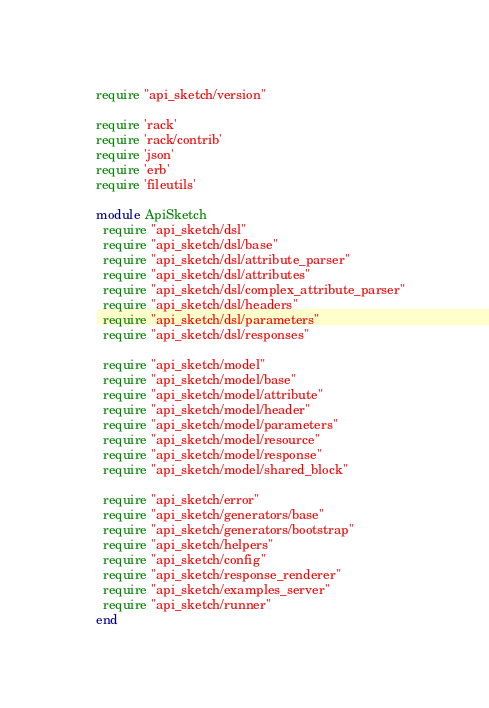<code> <loc_0><loc_0><loc_500><loc_500><_Ruby_>require "api_sketch/version"

require 'rack'
require 'rack/contrib'
require 'json'
require 'erb'
require 'fileutils'

module ApiSketch
  require "api_sketch/dsl"
  require "api_sketch/dsl/base"
  require "api_sketch/dsl/attribute_parser"
  require "api_sketch/dsl/attributes"
  require "api_sketch/dsl/complex_attribute_parser"
  require "api_sketch/dsl/headers"
  require "api_sketch/dsl/parameters"
  require "api_sketch/dsl/responses"

  require "api_sketch/model"
  require "api_sketch/model/base"
  require "api_sketch/model/attribute"
  require "api_sketch/model/header"
  require "api_sketch/model/parameters"
  require "api_sketch/model/resource"
  require "api_sketch/model/response"
  require "api_sketch/model/shared_block"

  require "api_sketch/error"
  require "api_sketch/generators/base"
  require "api_sketch/generators/bootstrap"
  require "api_sketch/helpers"
  require "api_sketch/config"
  require "api_sketch/response_renderer"
  require "api_sketch/examples_server"
  require "api_sketch/runner"
end
</code> 